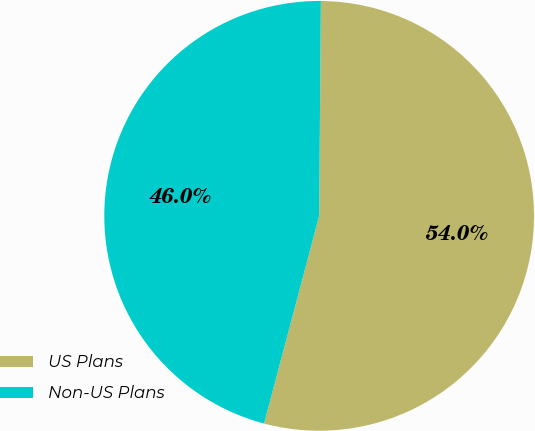Convert chart. <chart><loc_0><loc_0><loc_500><loc_500><pie_chart><fcel>US Plans<fcel>Non-US Plans<nl><fcel>54.0%<fcel>46.0%<nl></chart> 